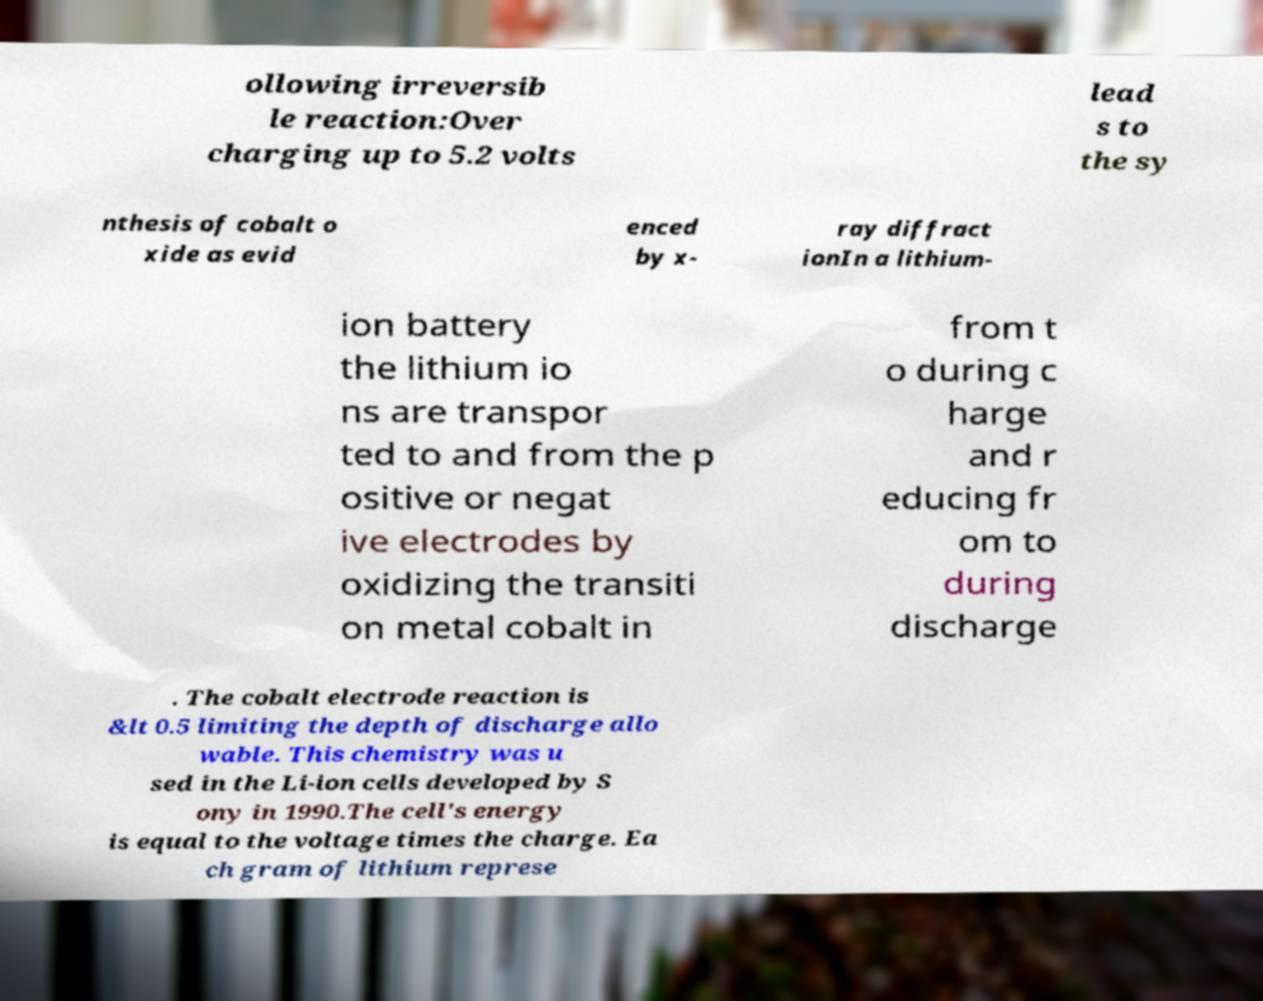For documentation purposes, I need the text within this image transcribed. Could you provide that? ollowing irreversib le reaction:Over charging up to 5.2 volts lead s to the sy nthesis of cobalt o xide as evid enced by x- ray diffract ionIn a lithium- ion battery the lithium io ns are transpor ted to and from the p ositive or negat ive electrodes by oxidizing the transiti on metal cobalt in from t o during c harge and r educing fr om to during discharge . The cobalt electrode reaction is &lt 0.5 limiting the depth of discharge allo wable. This chemistry was u sed in the Li-ion cells developed by S ony in 1990.The cell's energy is equal to the voltage times the charge. Ea ch gram of lithium represe 